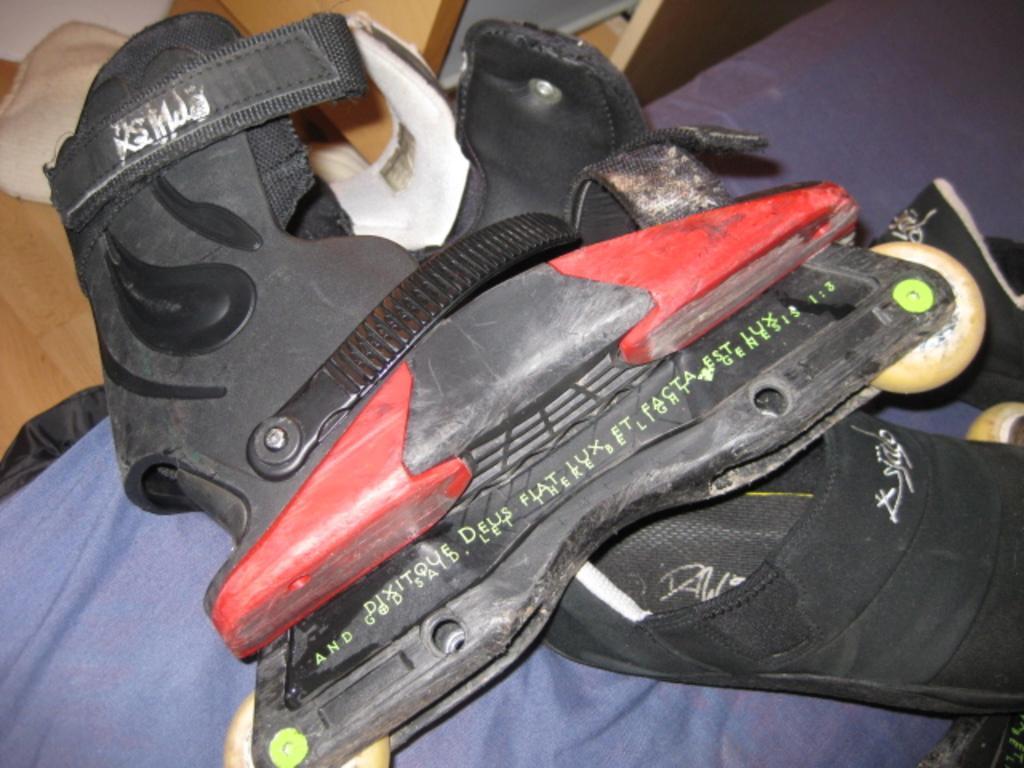Please provide a concise description of this image. There is a pair of a skating shoes as we can see in the middle of this image. 